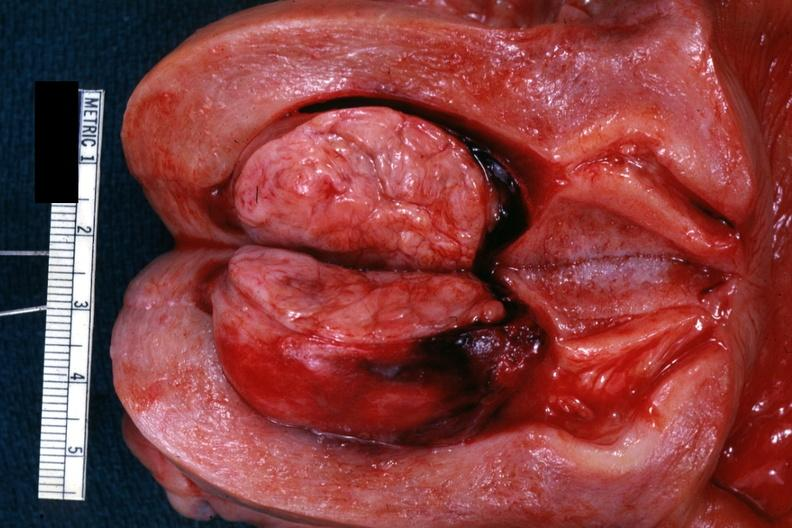where does this belong to?
Answer the question using a single word or phrase. Female reproductive system 